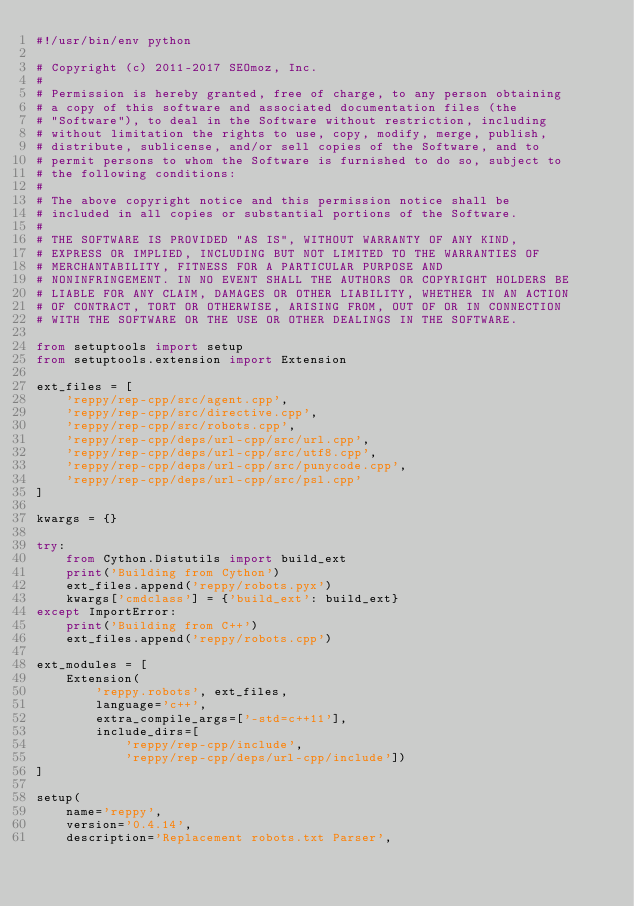Convert code to text. <code><loc_0><loc_0><loc_500><loc_500><_Python_>#!/usr/bin/env python

# Copyright (c) 2011-2017 SEOmoz, Inc.
#
# Permission is hereby granted, free of charge, to any person obtaining
# a copy of this software and associated documentation files (the
# "Software"), to deal in the Software without restriction, including
# without limitation the rights to use, copy, modify, merge, publish,
# distribute, sublicense, and/or sell copies of the Software, and to
# permit persons to whom the Software is furnished to do so, subject to
# the following conditions:
#
# The above copyright notice and this permission notice shall be
# included in all copies or substantial portions of the Software.
#
# THE SOFTWARE IS PROVIDED "AS IS", WITHOUT WARRANTY OF ANY KIND,
# EXPRESS OR IMPLIED, INCLUDING BUT NOT LIMITED TO THE WARRANTIES OF
# MERCHANTABILITY, FITNESS FOR A PARTICULAR PURPOSE AND
# NONINFRINGEMENT. IN NO EVENT SHALL THE AUTHORS OR COPYRIGHT HOLDERS BE
# LIABLE FOR ANY CLAIM, DAMAGES OR OTHER LIABILITY, WHETHER IN AN ACTION
# OF CONTRACT, TORT OR OTHERWISE, ARISING FROM, OUT OF OR IN CONNECTION
# WITH THE SOFTWARE OR THE USE OR OTHER DEALINGS IN THE SOFTWARE.

from setuptools import setup
from setuptools.extension import Extension

ext_files = [
    'reppy/rep-cpp/src/agent.cpp',
    'reppy/rep-cpp/src/directive.cpp',
    'reppy/rep-cpp/src/robots.cpp',
    'reppy/rep-cpp/deps/url-cpp/src/url.cpp',
    'reppy/rep-cpp/deps/url-cpp/src/utf8.cpp',
    'reppy/rep-cpp/deps/url-cpp/src/punycode.cpp',
    'reppy/rep-cpp/deps/url-cpp/src/psl.cpp'
]

kwargs = {}

try:
    from Cython.Distutils import build_ext
    print('Building from Cython')
    ext_files.append('reppy/robots.pyx')
    kwargs['cmdclass'] = {'build_ext': build_ext}
except ImportError:
    print('Building from C++')
    ext_files.append('reppy/robots.cpp')

ext_modules = [
    Extension(
        'reppy.robots', ext_files,
        language='c++',
        extra_compile_args=['-std=c++11'],
        include_dirs=[
            'reppy/rep-cpp/include',
            'reppy/rep-cpp/deps/url-cpp/include'])
]

setup(
    name='reppy',
    version='0.4.14',
    description='Replacement robots.txt Parser',</code> 